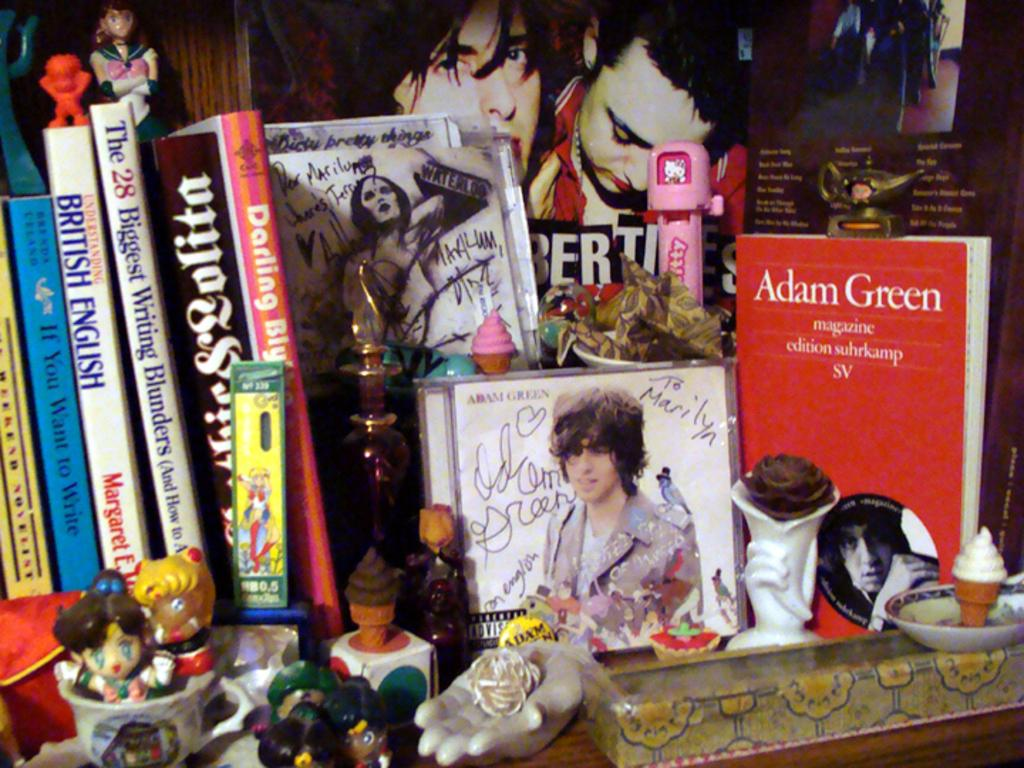<image>
Describe the image concisely. the name adam green is on the red book 